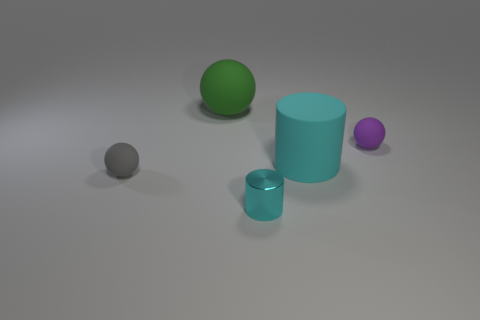Subtract all brown cylinders. Subtract all brown balls. How many cylinders are left? 2 Subtract all purple cylinders. How many brown spheres are left? 0 Add 3 small purples. How many tiny cyans exist? 0 Subtract all tiny yellow matte cylinders. Subtract all metallic cylinders. How many objects are left? 4 Add 3 big cyan cylinders. How many big cyan cylinders are left? 4 Add 4 gray rubber things. How many gray rubber things exist? 5 Add 3 metal things. How many objects exist? 8 Subtract all green balls. How many balls are left? 2 Subtract all green spheres. How many spheres are left? 2 Subtract 0 yellow cylinders. How many objects are left? 5 